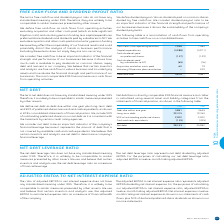According to Bce's financial document, How is net debt defined? debt due within one year plus long-term debt and 50% of preferred shares, less cash and cash equivalents, as shown in BCE’s consolidated statements of financial position. The document states: "We define net debt as debt due within one year plus long-term debt and 50% of preferred shares, less cash and cash equivalents, as shown in BCE’s cons..." Also, Why is net debt considered as an important indicator of the company's financial leverage? Because it represents the amount of debt that is not covered by available cash and cash equivalents.. The document states: "tant indicator of the company’s financial leverage because it represents the amount of debt that is not covered by available cash and cash equivalents..." Also, What is the Debt due within one year for 2019? According to the financial document, 3,881. The relevant text states: "Debt due within one year 3,881 4,645..." Also, can you calculate: What is the change in the debt due within one year in 2019? Based on the calculation: 3,881-4,645, the result is -764. This is based on the information: "Debt due within one year 3,881 4,645 Debt due within one year 3,881 4,645..." The key data points involved are: 3,881, 4,645. Also, can you calculate: What is the percentage change in long-term debt in 2019? To answer this question, I need to perform calculations using the financial data. The calculation is: (22,415-19,760)/19,760, which equals 13.44 (percentage). This is based on the information: "Long-term debt 22,415 19,760 Long-term debt 22,415 19,760..." The key data points involved are: 19,760, 22,415. Also, can you calculate: What is the change in net debt in 2019? Based on the calculation: 28,153-25,982, the result is 2171. This is based on the information: "Net debt 28,153 25,982 Net debt 28,153 25,982..." The key data points involved are: 25,982, 28,153. 